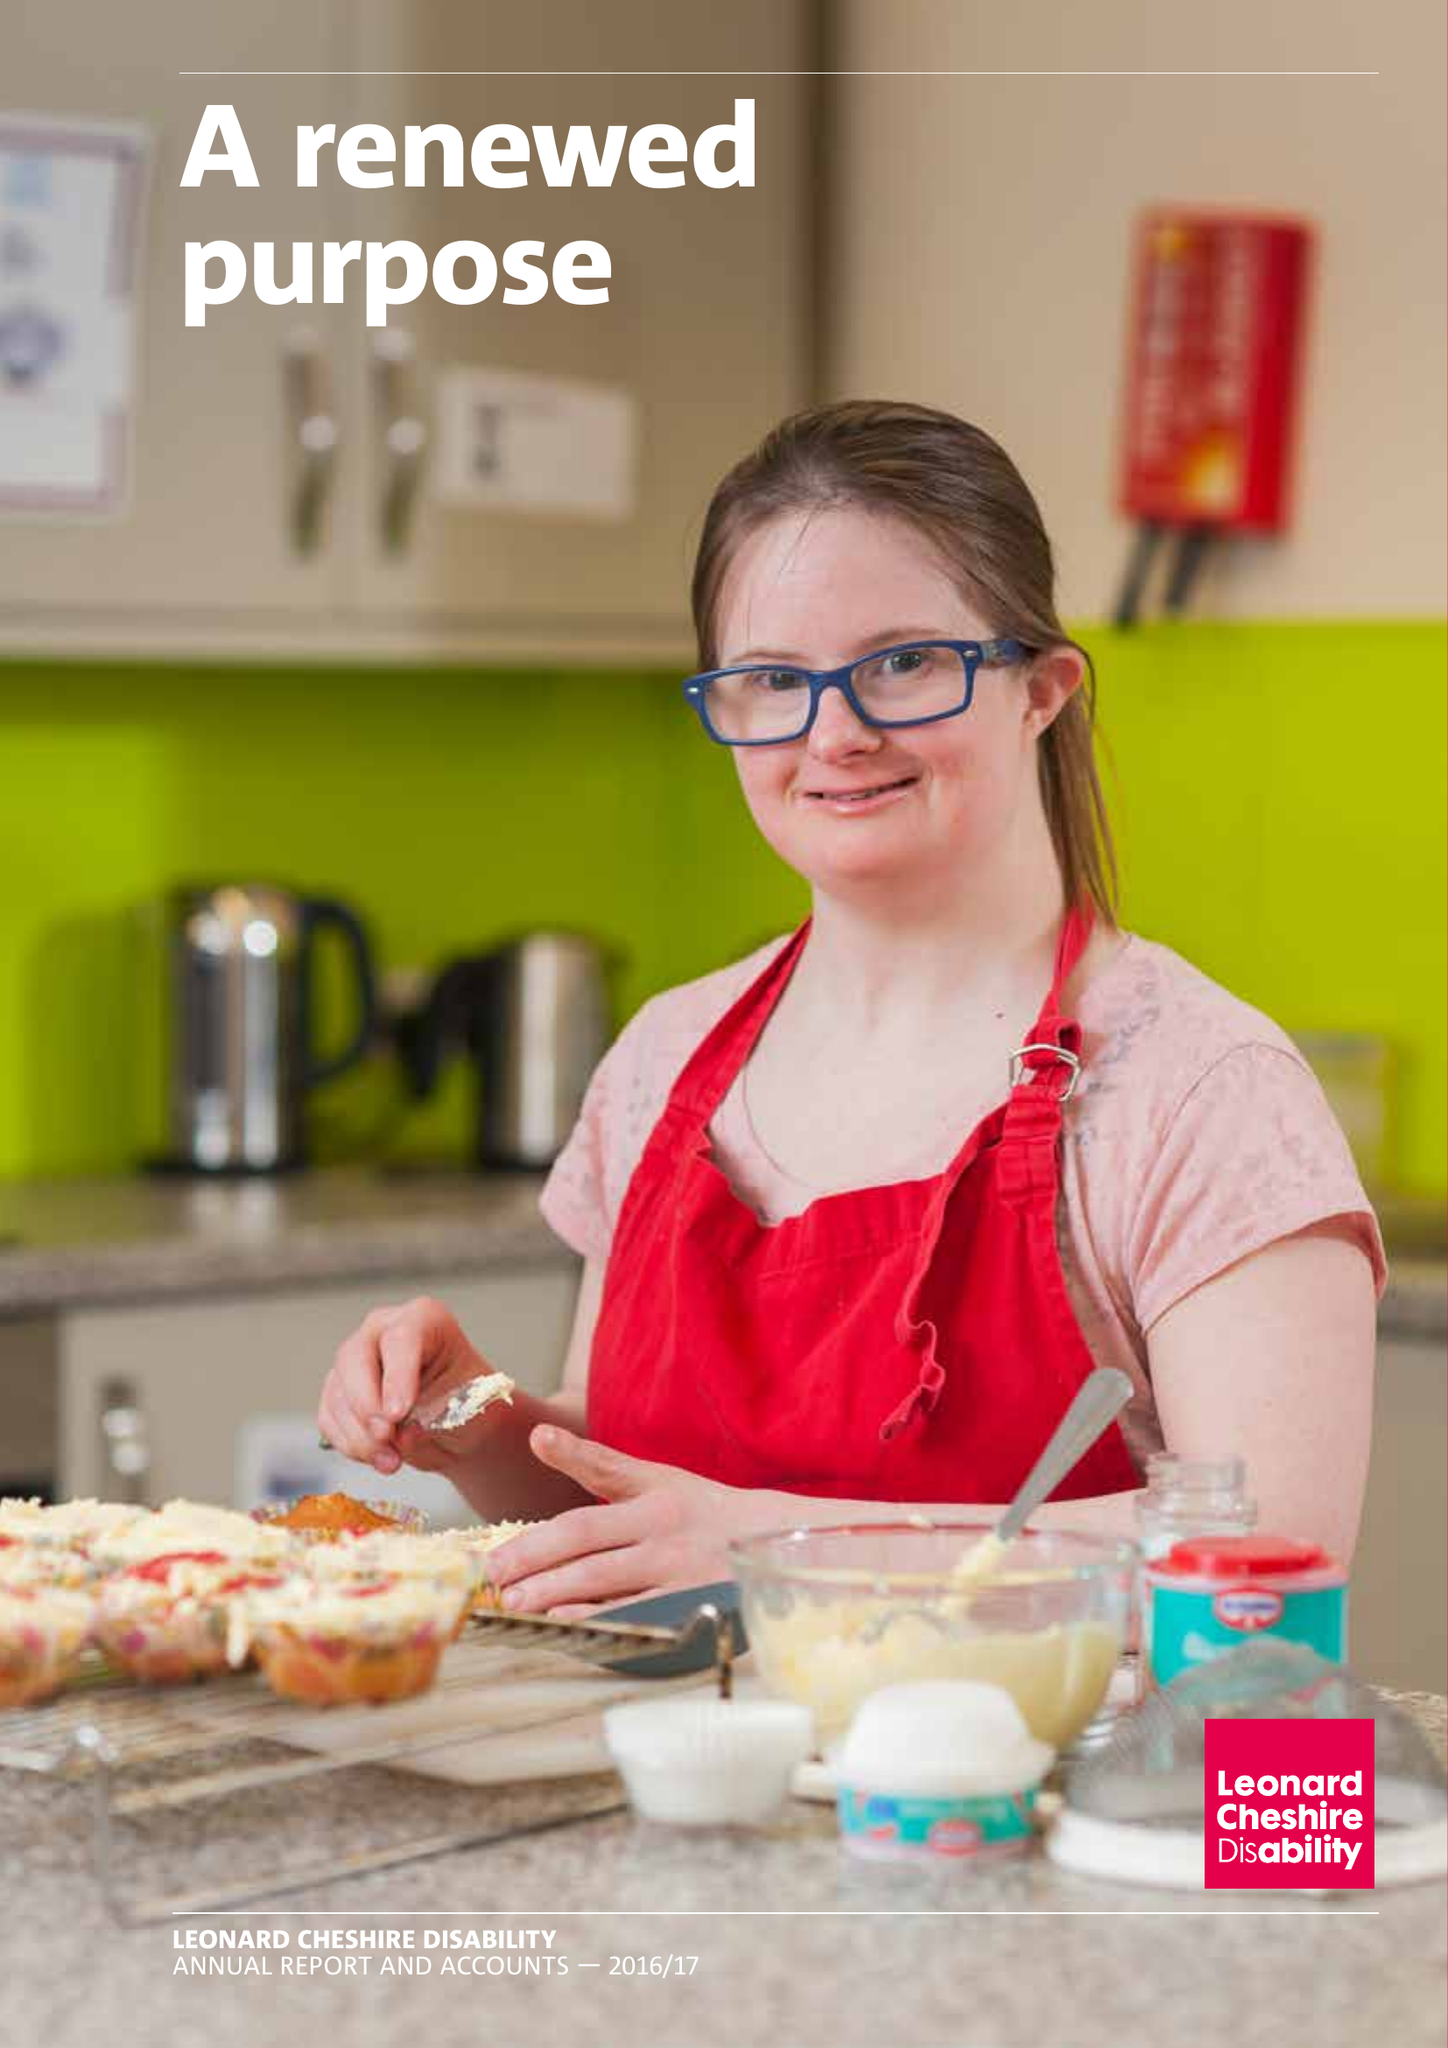What is the value for the address__street_line?
Answer the question using a single word or phrase. 66 SOUTH LAMBETH ROAD 